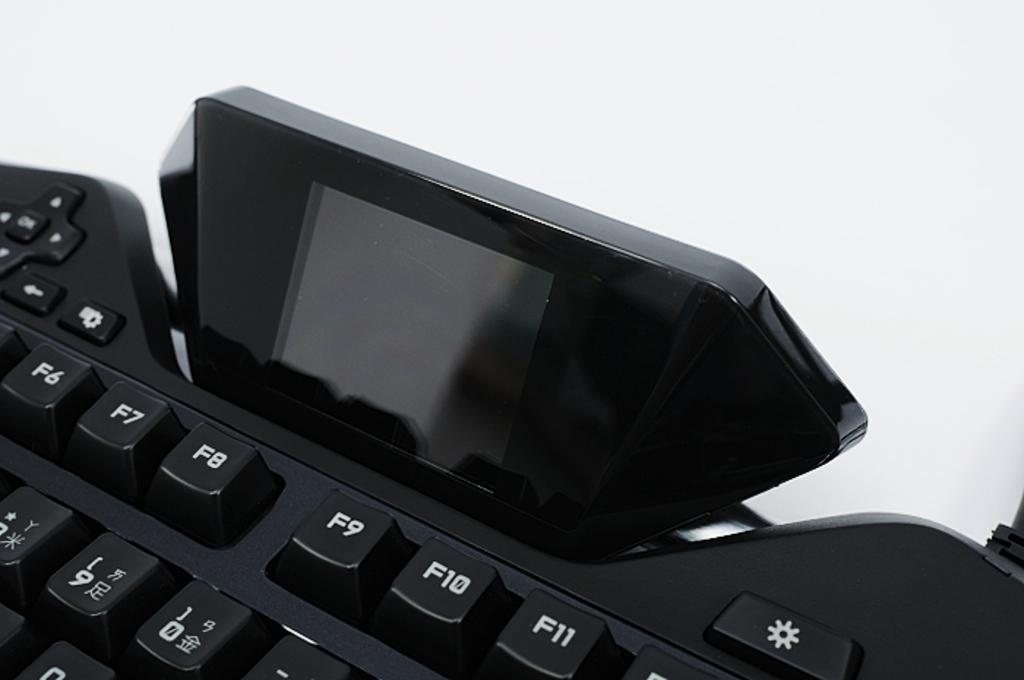<image>
Write a terse but informative summary of the picture. A black computer keyboard with a small screen attached and the keys F6-F11 displayed 